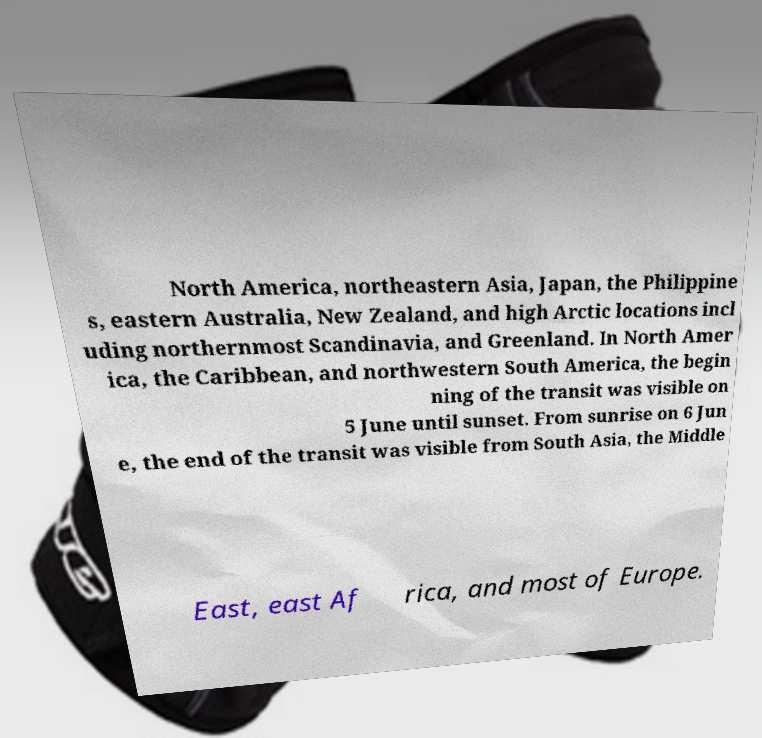Please read and relay the text visible in this image. What does it say? North America, northeastern Asia, Japan, the Philippine s, eastern Australia, New Zealand, and high Arctic locations incl uding northernmost Scandinavia, and Greenland. In North Amer ica, the Caribbean, and northwestern South America, the begin ning of the transit was visible on 5 June until sunset. From sunrise on 6 Jun e, the end of the transit was visible from South Asia, the Middle East, east Af rica, and most of Europe. 